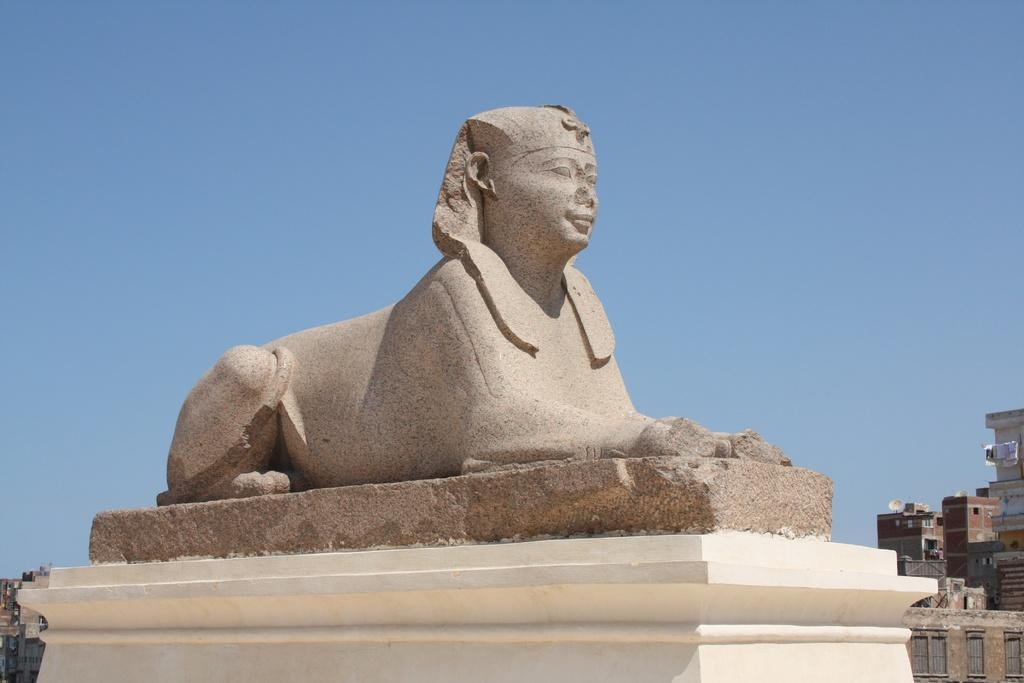What is the main subject of the image? There is a sculpture in the image. What can be seen on the right side of the image? There are buildings on the right side of the image. What can be seen on the left side of the image? There are buildings on the left side of the image. What is visible in the background of the image? The sky is visible in the background of the image. Can you tell me how many spies are hiding behind the sculpture in the image? There are no spies present in the image; it features a sculpture and buildings. What type of monkey can be seen climbing the sculpture in the image? There is no monkey present in the image; it only features a sculpture and buildings. 